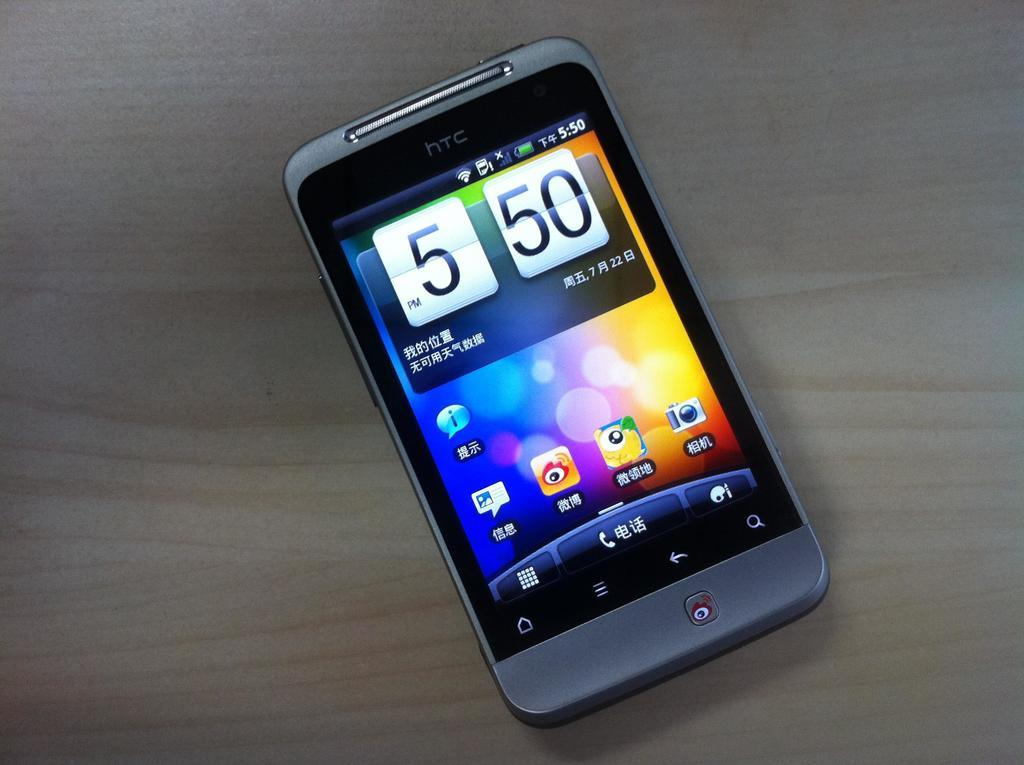<image>
Create a compact narrative representing the image presented. a phone that has the time of 550 on it 